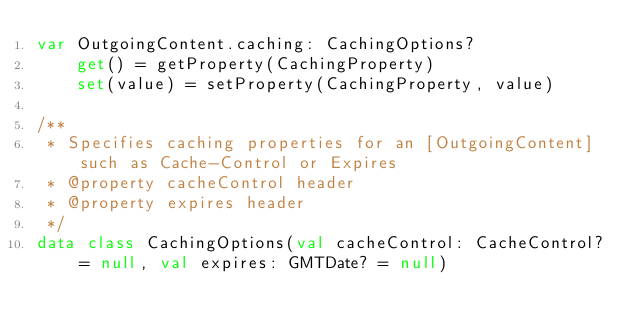<code> <loc_0><loc_0><loc_500><loc_500><_Kotlin_>var OutgoingContent.caching: CachingOptions?
    get() = getProperty(CachingProperty)
    set(value) = setProperty(CachingProperty, value)

/**
 * Specifies caching properties for an [OutgoingContent] such as Cache-Control or Expires
 * @property cacheControl header
 * @property expires header
 */
data class CachingOptions(val cacheControl: CacheControl? = null, val expires: GMTDate? = null)
</code> 